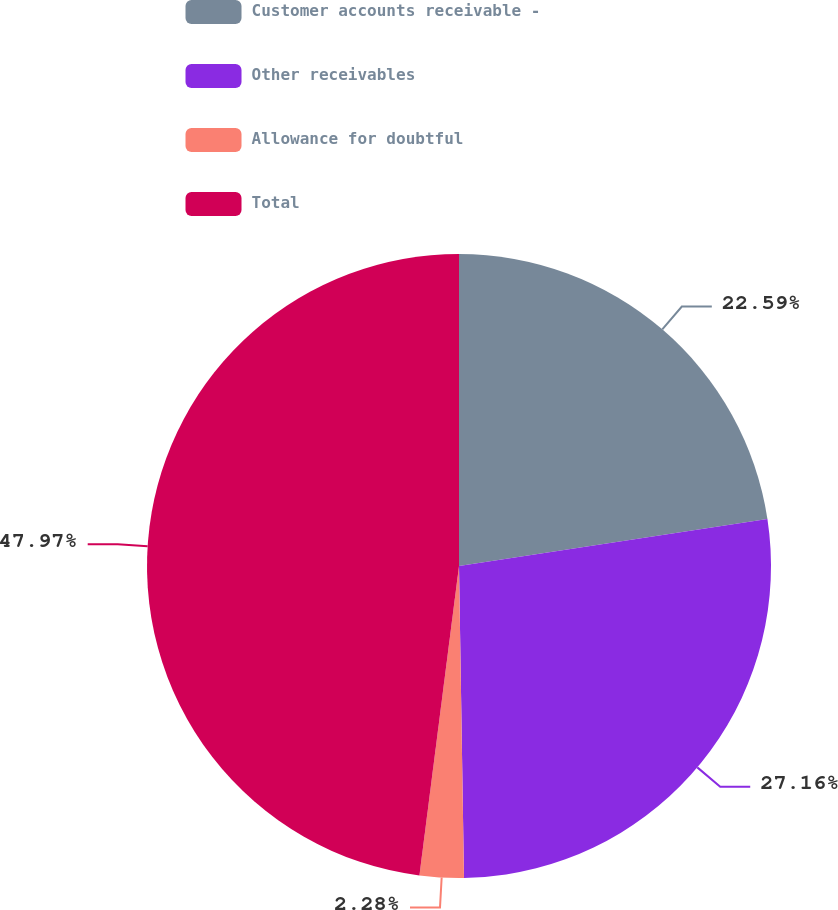Convert chart. <chart><loc_0><loc_0><loc_500><loc_500><pie_chart><fcel>Customer accounts receivable -<fcel>Other receivables<fcel>Allowance for doubtful<fcel>Total<nl><fcel>22.59%<fcel>27.16%<fcel>2.28%<fcel>47.98%<nl></chart> 